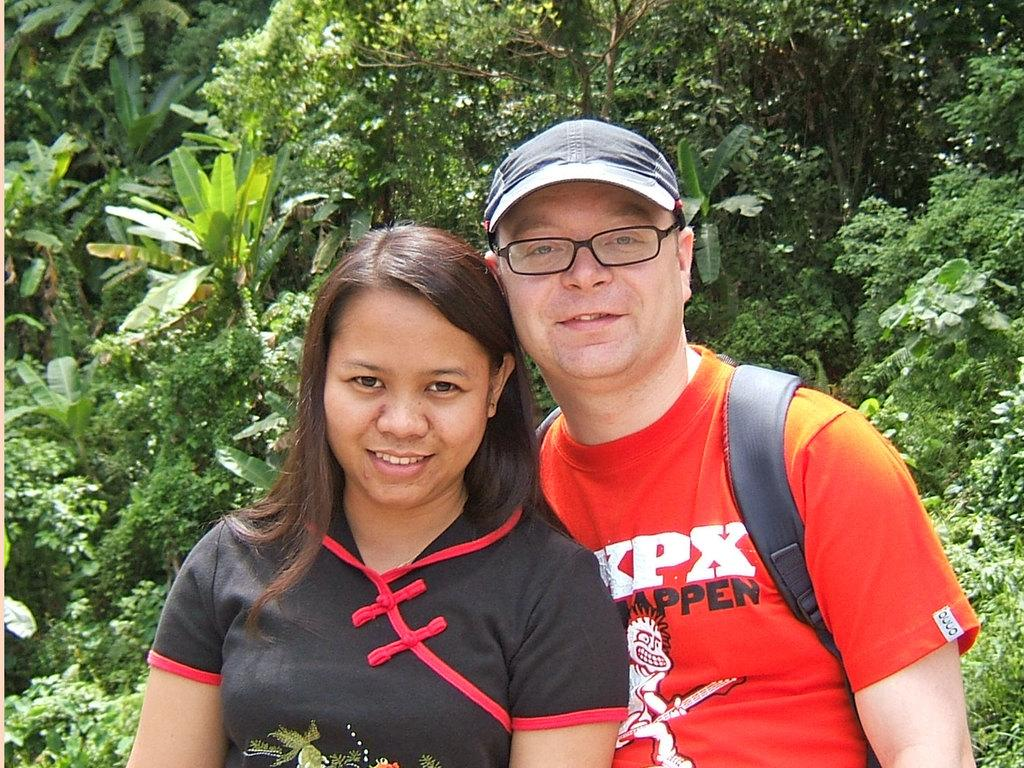What is the gender of the person in the image? There is a man and a woman in the image. What is the man wearing in the image? The man is wearing glasses (specs) in the image. What is the man carrying in the image? The man is carrying a bag in the image. What can be seen in the background of the image? There is a cab, trees, and plants in the background of the image. What type of throat lozenges can be seen in the man's hand in the image? There are no throat lozenges visible in the man's hand in the image. What type of market is visible in the background of the image? There is no market visible in the background of the image; it features a cab, trees, and plants. 